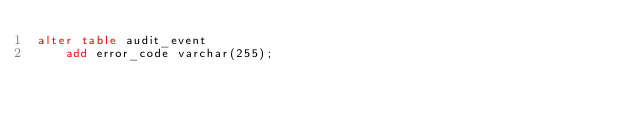Convert code to text. <code><loc_0><loc_0><loc_500><loc_500><_SQL_>alter table audit_event
    add error_code varchar(255);
</code> 